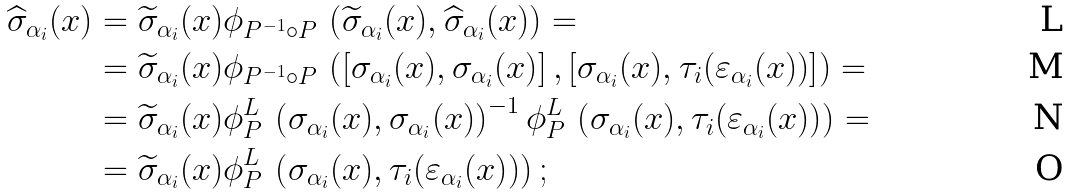Convert formula to latex. <formula><loc_0><loc_0><loc_500><loc_500>\widehat { \sigma } _ { \alpha _ { i } } ( x ) & = \widetilde { \sigma } _ { \alpha _ { i } } ( x ) \phi _ { P ^ { - 1 } \circ P } \, \left ( \widetilde { \sigma } _ { \alpha _ { i } } ( x ) , \widehat { \sigma } _ { \alpha _ { i } } ( x ) \right ) = \\ & = \widetilde { \sigma } _ { \alpha _ { i } } ( x ) \phi _ { P ^ { - 1 } \circ P } \, \left ( \left [ \sigma _ { \alpha _ { i } } ( x ) , \sigma _ { \alpha _ { i } } ( x ) \right ] , \left [ \sigma _ { \alpha _ { i } } ( x ) , \tau _ { i } ( \varepsilon _ { \alpha _ { i } } ( x ) ) \right ] \right ) = \\ & = \widetilde { \sigma } _ { \alpha _ { i } } ( x ) \phi _ { P } ^ { L } \, \left ( \sigma _ { \alpha _ { i } } ( x ) , \sigma _ { \alpha _ { i } } ( x ) \right ) ^ { - 1 } \phi _ { P } ^ { L } \, \left ( \sigma _ { \alpha _ { i } } ( x ) , \tau _ { i } ( \varepsilon _ { \alpha _ { i } } ( x ) ) \right ) = \\ & = \widetilde { \sigma } _ { \alpha _ { i } } ( x ) \phi _ { P } ^ { L } \, \left ( \sigma _ { \alpha _ { i } } ( x ) , \tau _ { i } ( \varepsilon _ { \alpha _ { i } } ( x ) ) \right ) ;</formula> 